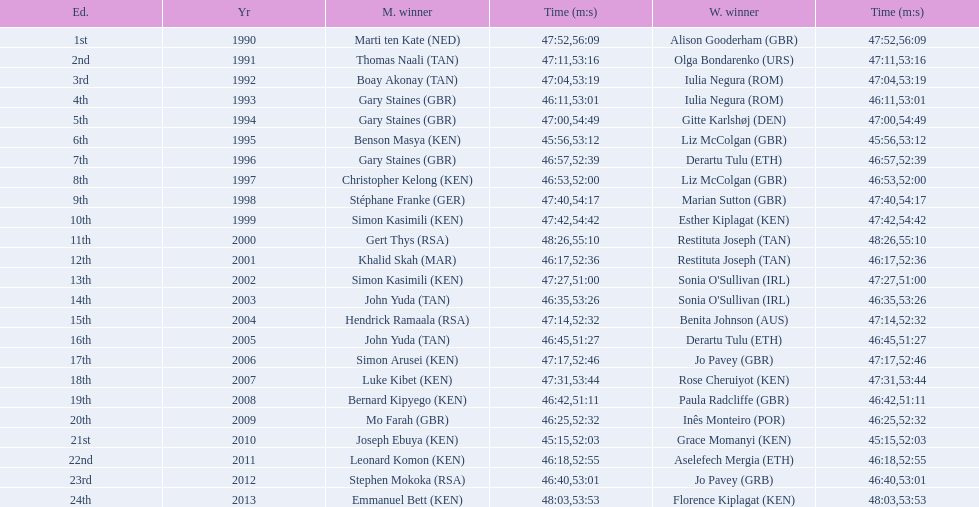How long did sonia o'sullivan take to finish in 2003? 53:26. 